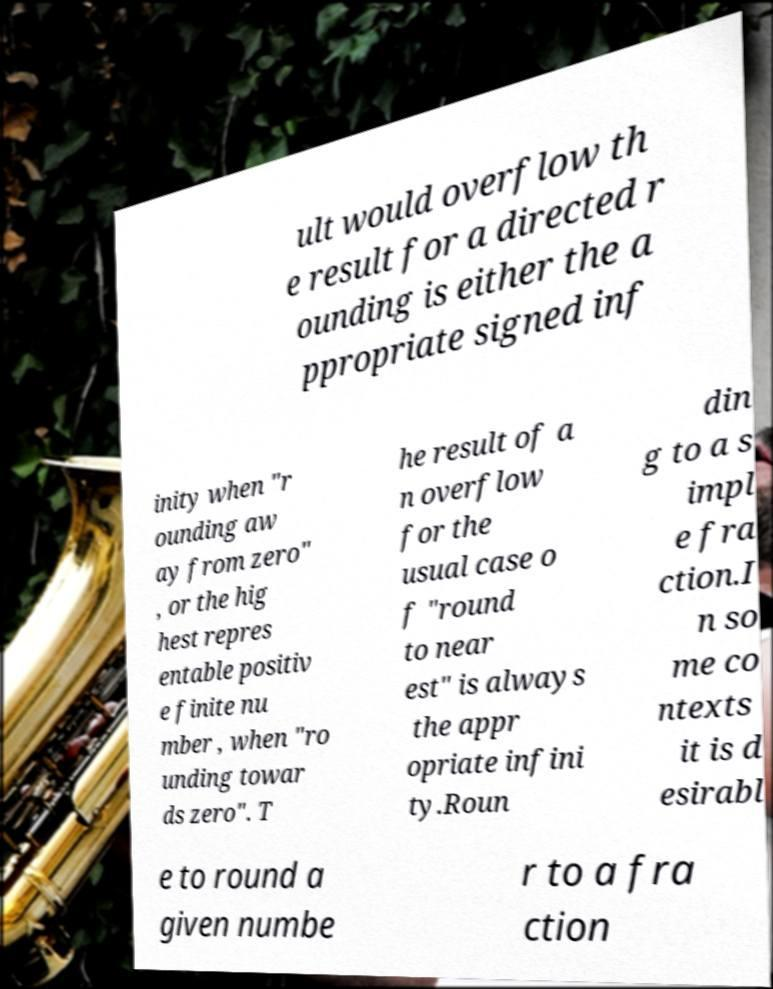Can you read and provide the text displayed in the image?This photo seems to have some interesting text. Can you extract and type it out for me? ult would overflow th e result for a directed r ounding is either the a ppropriate signed inf inity when "r ounding aw ay from zero" , or the hig hest repres entable positiv e finite nu mber , when "ro unding towar ds zero". T he result of a n overflow for the usual case o f "round to near est" is always the appr opriate infini ty.Roun din g to a s impl e fra ction.I n so me co ntexts it is d esirabl e to round a given numbe r to a fra ction 